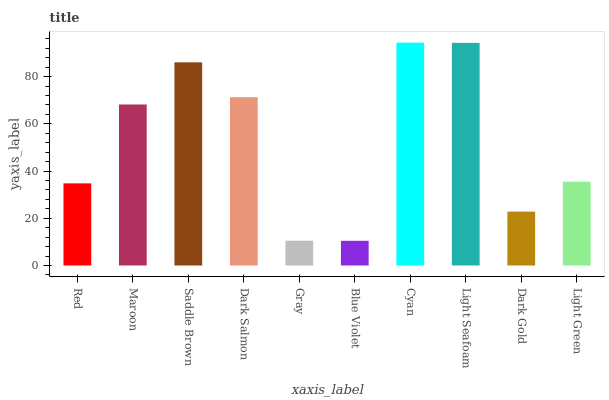Is Blue Violet the minimum?
Answer yes or no. Yes. Is Cyan the maximum?
Answer yes or no. Yes. Is Maroon the minimum?
Answer yes or no. No. Is Maroon the maximum?
Answer yes or no. No. Is Maroon greater than Red?
Answer yes or no. Yes. Is Red less than Maroon?
Answer yes or no. Yes. Is Red greater than Maroon?
Answer yes or no. No. Is Maroon less than Red?
Answer yes or no. No. Is Maroon the high median?
Answer yes or no. Yes. Is Light Green the low median?
Answer yes or no. Yes. Is Red the high median?
Answer yes or no. No. Is Gray the low median?
Answer yes or no. No. 